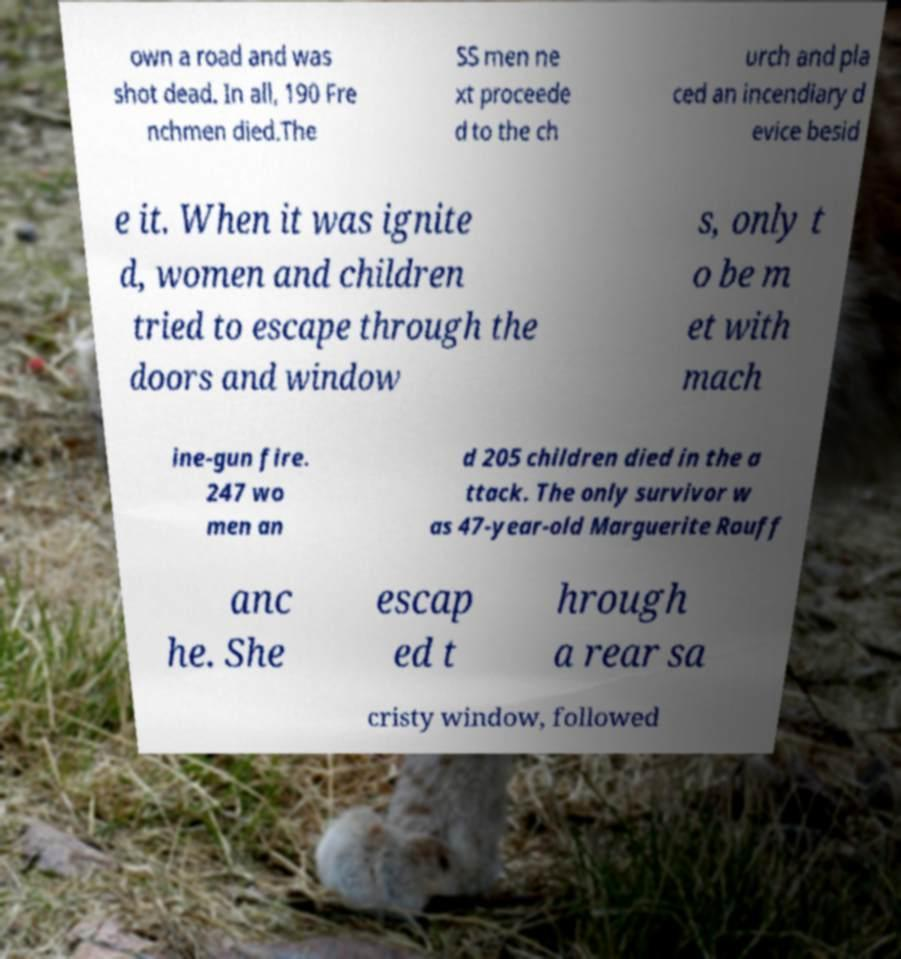Can you accurately transcribe the text from the provided image for me? own a road and was shot dead. In all, 190 Fre nchmen died.The SS men ne xt proceede d to the ch urch and pla ced an incendiary d evice besid e it. When it was ignite d, women and children tried to escape through the doors and window s, only t o be m et with mach ine-gun fire. 247 wo men an d 205 children died in the a ttack. The only survivor w as 47-year-old Marguerite Rouff anc he. She escap ed t hrough a rear sa cristy window, followed 